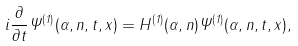<formula> <loc_0><loc_0><loc_500><loc_500>i \frac { \partial } { \partial t } \Psi ^ { ( 1 ) } ( \alpha , n , t , x ) = H ^ { ( 1 ) } ( \alpha , n ) \Psi ^ { ( 1 ) } ( \alpha , n , t , x ) ,</formula> 